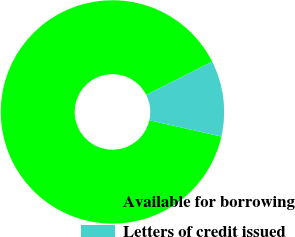<chart> <loc_0><loc_0><loc_500><loc_500><pie_chart><fcel>Available for borrowing<fcel>Letters of credit issued<nl><fcel>89.02%<fcel>10.98%<nl></chart> 